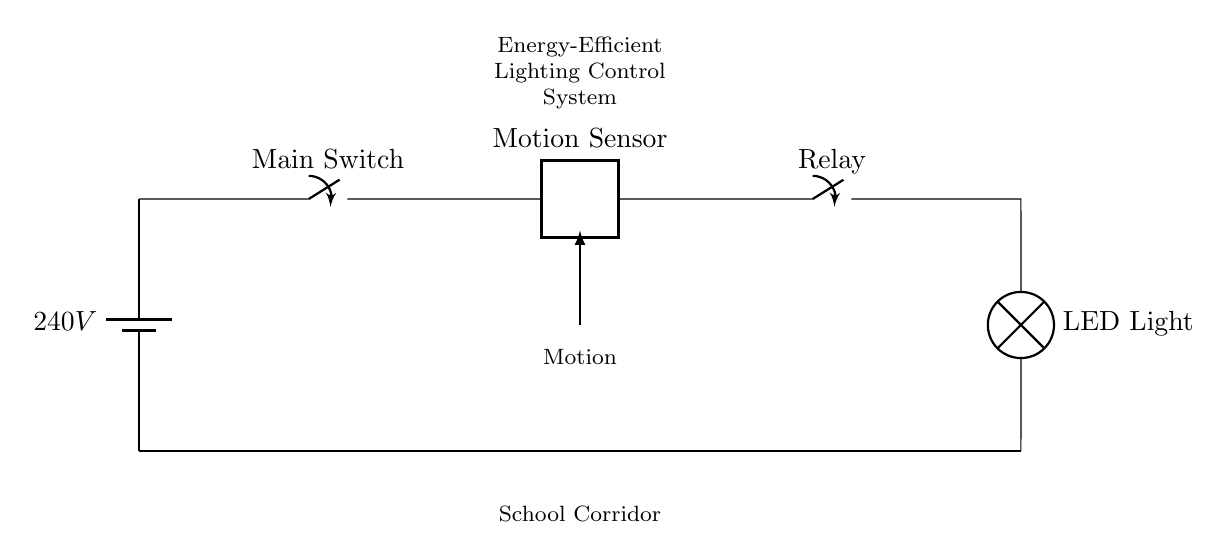What is the power supply voltage of the circuit? The circuit is powered by a battery labeled as 240V, which is indicated at the left side of the diagram.
Answer: 240V What component detects motion in the corridor? The motion sensor, which is positioned between the main switch and the relay, is responsible for detecting motion. It is labeled clearly in the circuit diagram.
Answer: Motion Sensor What does the relay do in this circuit? The relay acts as a switch that opens or closes based on signals from the motion sensor. When motion is detected, it closes to allow power to flow to the LED light.
Answer: Relay What type of lighting is used in the system? The circuit diagram indicates that an LED light is used for illumination in the school corridor, which is energy-efficient.
Answer: LED Light How many primary components are in the circuit? The circuit contains five primary components: battery, main switch, motion sensor, relay, and LED light. Counting these gives a total of five.
Answer: Five What is the purpose of the main switch? The main switch is used to turn the entire lighting control system on or off. When closed, it allows power from the battery to flow into the rest of the circuit.
Answer: To control power What triggers the LED light to turn on? The LED light is triggered to turn on by the closing of the relay, which is activated when the motion sensor detects movement in the corridor.
Answer: Motion detection 